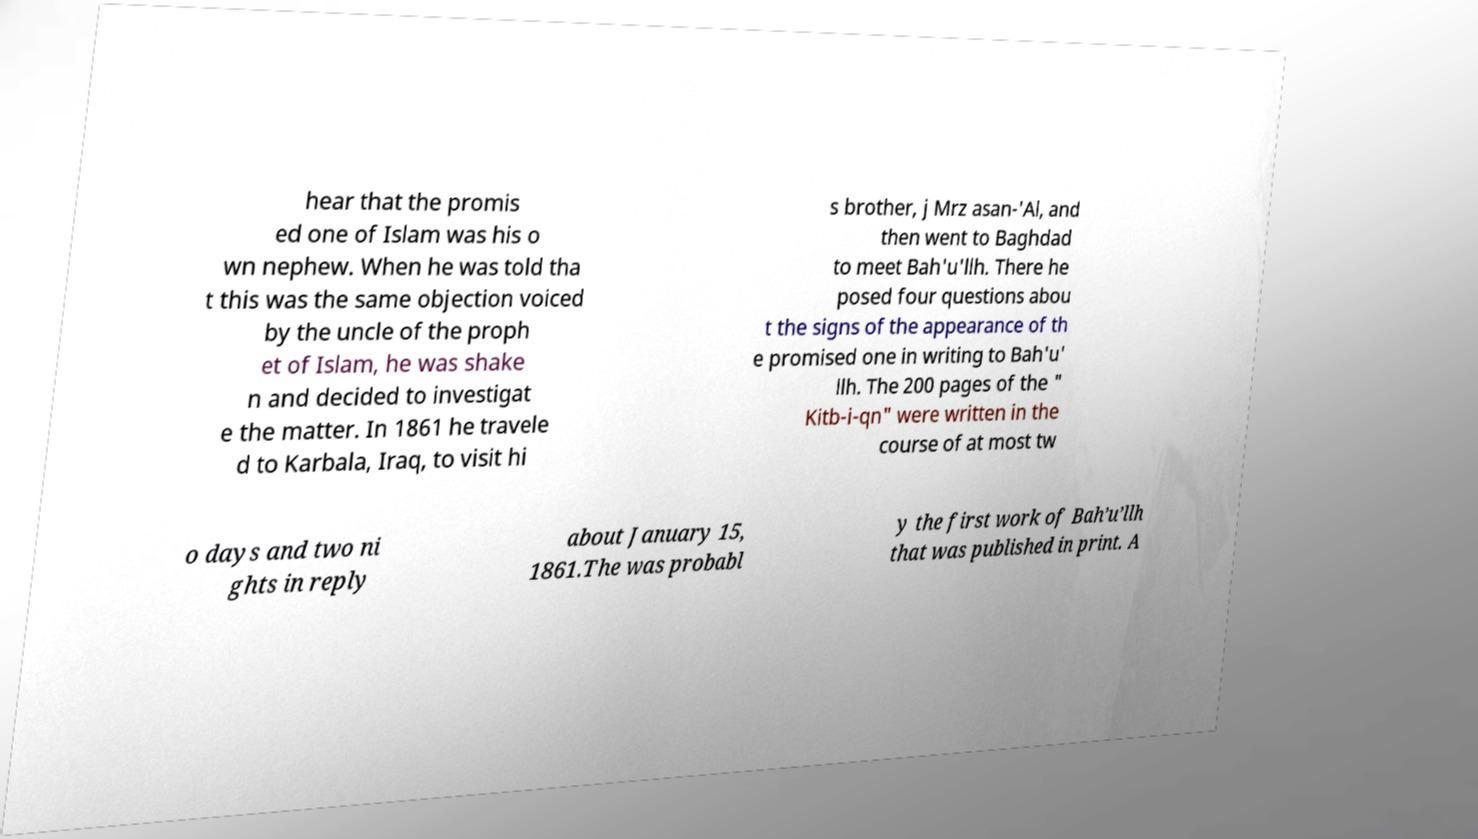Can you accurately transcribe the text from the provided image for me? hear that the promis ed one of Islam was his o wn nephew. When he was told tha t this was the same objection voiced by the uncle of the proph et of Islam, he was shake n and decided to investigat e the matter. In 1861 he travele d to Karbala, Iraq, to visit hi s brother, j Mrz asan-'Al, and then went to Baghdad to meet Bah'u'llh. There he posed four questions abou t the signs of the appearance of th e promised one in writing to Bah'u' llh. The 200 pages of the " Kitb-i-qn" were written in the course of at most tw o days and two ni ghts in reply about January 15, 1861.The was probabl y the first work of Bah’u’llh that was published in print. A 